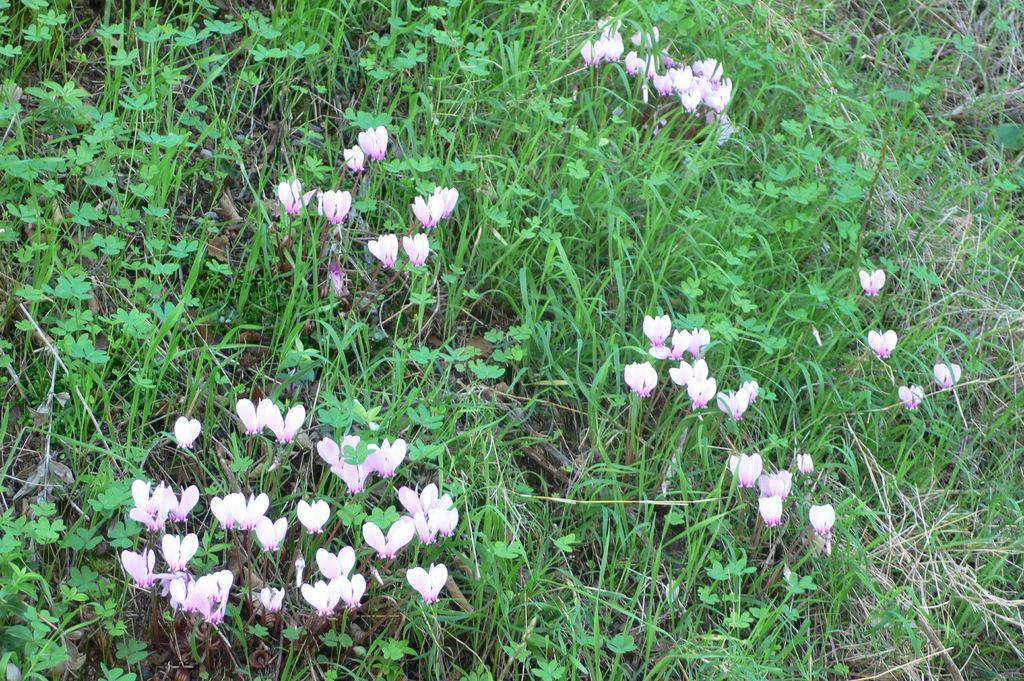What type of vegetation can be seen in the image? There is grass in the image. What other natural elements are present in the image? There are flowers in the image. What type of clock is hanging on the wall in the image? There is no clock or wall present in the image; it only features grass and flowers. 